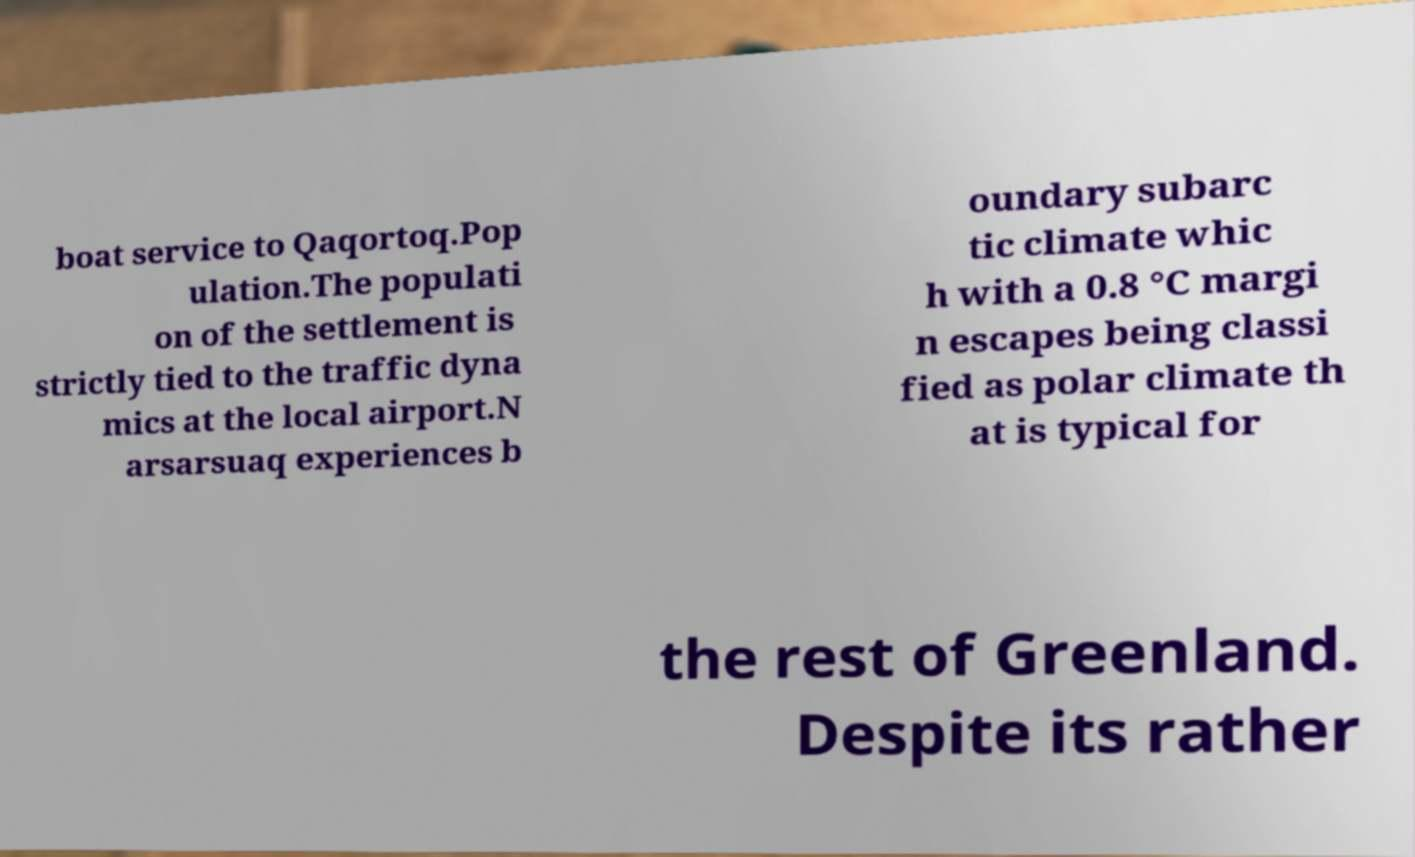Please read and relay the text visible in this image. What does it say? boat service to Qaqortoq.Pop ulation.The populati on of the settlement is strictly tied to the traffic dyna mics at the local airport.N arsarsuaq experiences b oundary subarc tic climate whic h with a 0.8 °C margi n escapes being classi fied as polar climate th at is typical for the rest of Greenland. Despite its rather 